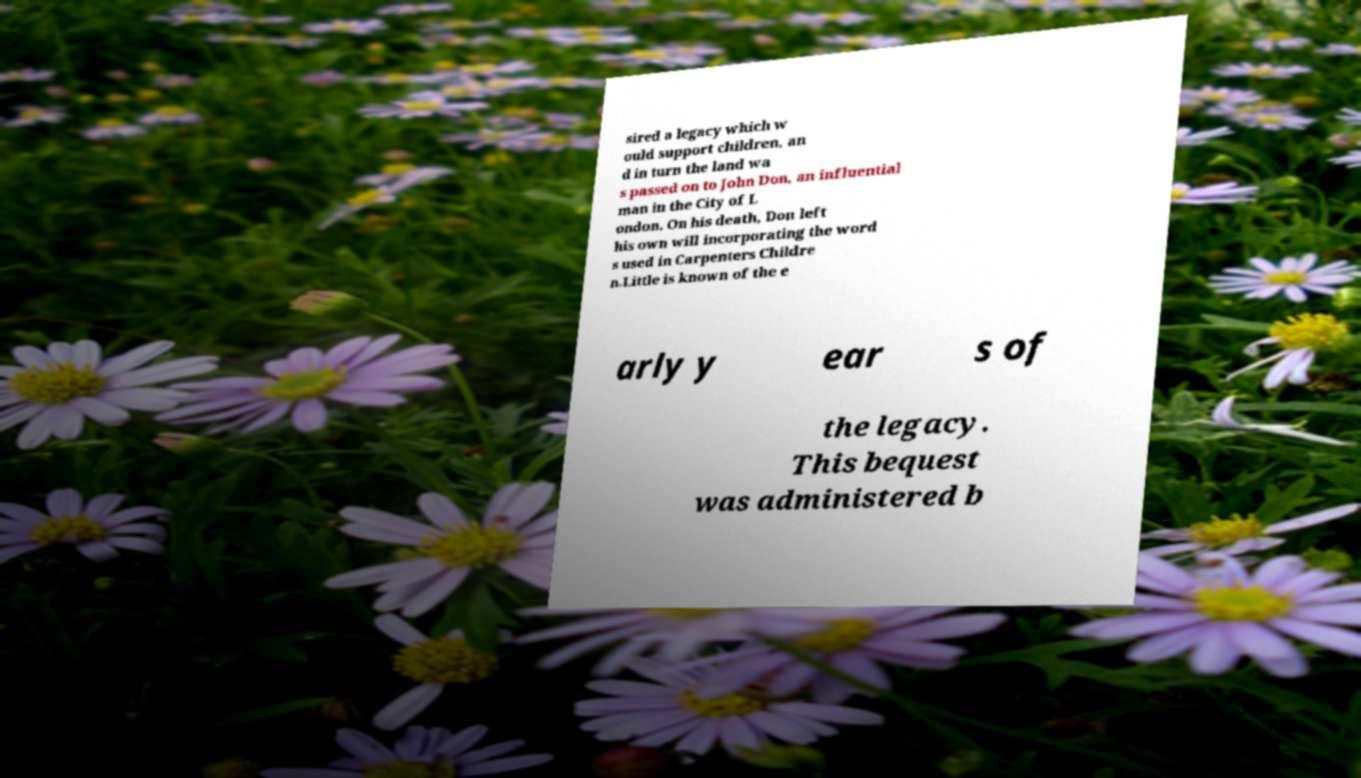Can you accurately transcribe the text from the provided image for me? sired a legacy which w ould support children, an d in turn the land wa s passed on to John Don, an influential man in the City of L ondon. On his death, Don left his own will incorporating the word s used in Carpenters Childre n.Little is known of the e arly y ear s of the legacy. This bequest was administered b 